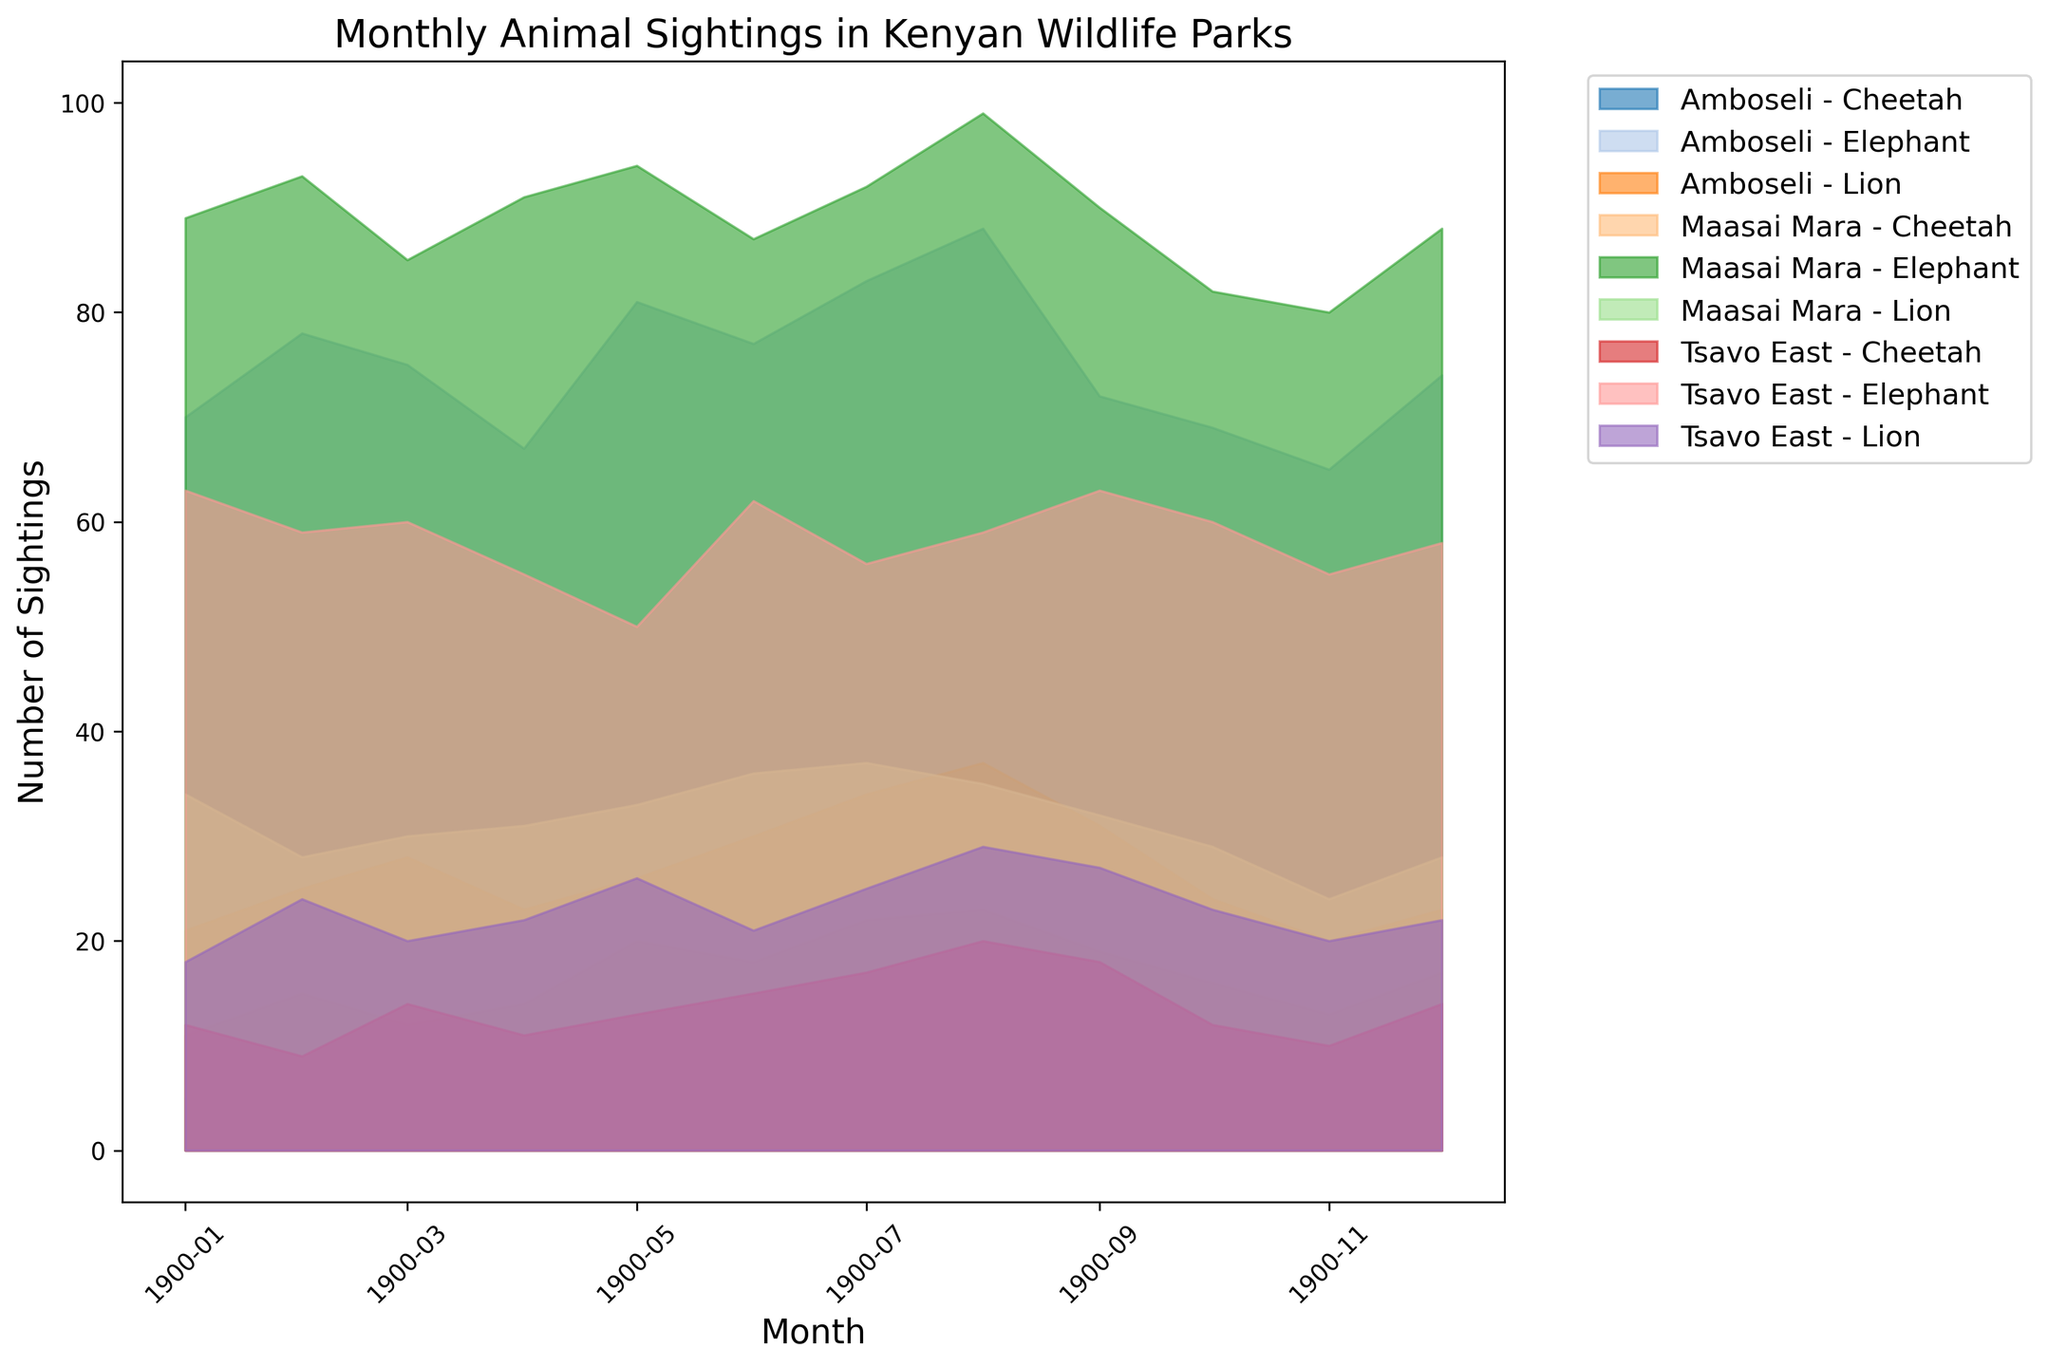What month and park had the highest number of elephant sightings? First, identify the elephant sighting data in each park. In Maasai Mara, September has the highest number (99), which is easy to spot from the visual. Then, check Amboseli and Tsavo East. Amboseli's highest is August (88) and Tsavo East's highest is January and September (63). Comparing all these, Maasai Mara in August surpasses others.
Answer: August in Maasai Mara Which park had the most lion sightings in January? Observe the January data for lions in all parks. Maasai Mara has 34, Amboseli has 11, and Tsavo East has 18. Among these, Maasai Mara has the highest number.
Answer: Maasai Mara In which month was the difference between lion sightings in Maasai Mara and Amboseli the greatest? Calculate the monthly differences. E.g., in January: 34 (Maasai Mara) - 11 (Amboseli) = 23. Repeat for each month. August has the greatest difference: 35 (Maasai Mara) - 23 (Amboseli) = 12.
Answer: August When comparing Cheetah sightings in June and September in Tsavo East, which month had more sightings? Locate June and September data for Cheetah sightings in Tsavo East. June has 15, and September has 18. Comparing these, September has more sightings.
Answer: September In which month did Amboseli have its lowest elephant sightings? Check Amboseli's monthly data for the lowest value. The lowest sighting is in January (70).
Answer: January Which species had the highest sighting spike in Tsavo East between two consecutive months? Identify the month-to-month changes for each species in Tsavo East and look for the largest increase. Cheetah sightings from July (17) to August (20) have the largest spike (+3).
Answer: Cheetah What was the average number of lion sightings in Maasai Mara from July to September? Sum the sightings from July (37), August (35), and September (32). Their average is (37 + 35 + 32) / 3.
Answer: 34.7 Did any species' sightings in Maasai Mara decline every month consecutively from March to June? Check the sightings for each species in Maasai Mara for the given period. None of the species show a consistent decline every month during this time span.
Answer: No How do the overall sightings of elephants in Amboseli compare to Tsavo East in the first quarter of the year? Sum elephant sightings in Amboseli: January (70) + February (78) + March (75) = 223. Tsavo East: January (63) + February (59) + March (60) = 182. Amboseli has higher total sightings.
Answer: Amboseli has more 